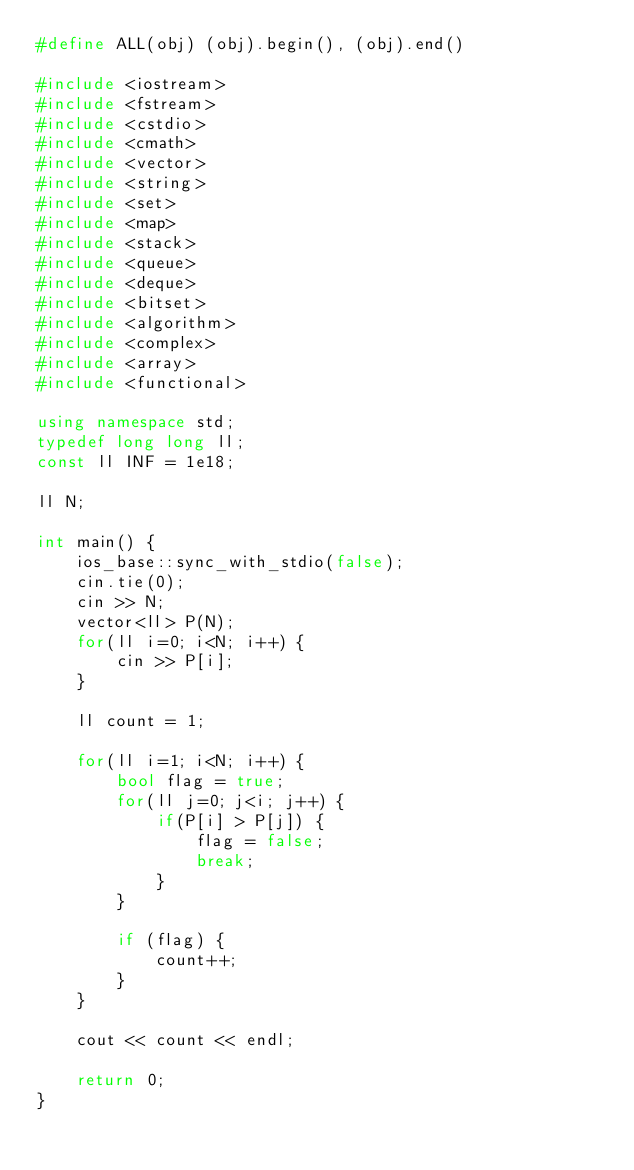<code> <loc_0><loc_0><loc_500><loc_500><_C++_>#define ALL(obj) (obj).begin(), (obj).end()

#include <iostream>
#include <fstream>
#include <cstdio>
#include <cmath>
#include <vector>
#include <string>
#include <set>
#include <map>
#include <stack>
#include <queue>
#include <deque>
#include <bitset>
#include <algorithm>
#include <complex>
#include <array>
#include <functional>

using namespace std;
typedef long long ll;
const ll INF = 1e18;

ll N;

int main() {
    ios_base::sync_with_stdio(false);
    cin.tie(0);
    cin >> N;
    vector<ll> P(N);
    for(ll i=0; i<N; i++) {
        cin >> P[i];
    }
    
    ll count = 1;
    
    for(ll i=1; i<N; i++) {
        bool flag = true;
        for(ll j=0; j<i; j++) {
            if(P[i] > P[j]) {
                flag = false;
                break;
            }
        }
        
        if (flag) {
            count++;
        }
    }
    
    cout << count << endl;
    
    return 0;
}
</code> 